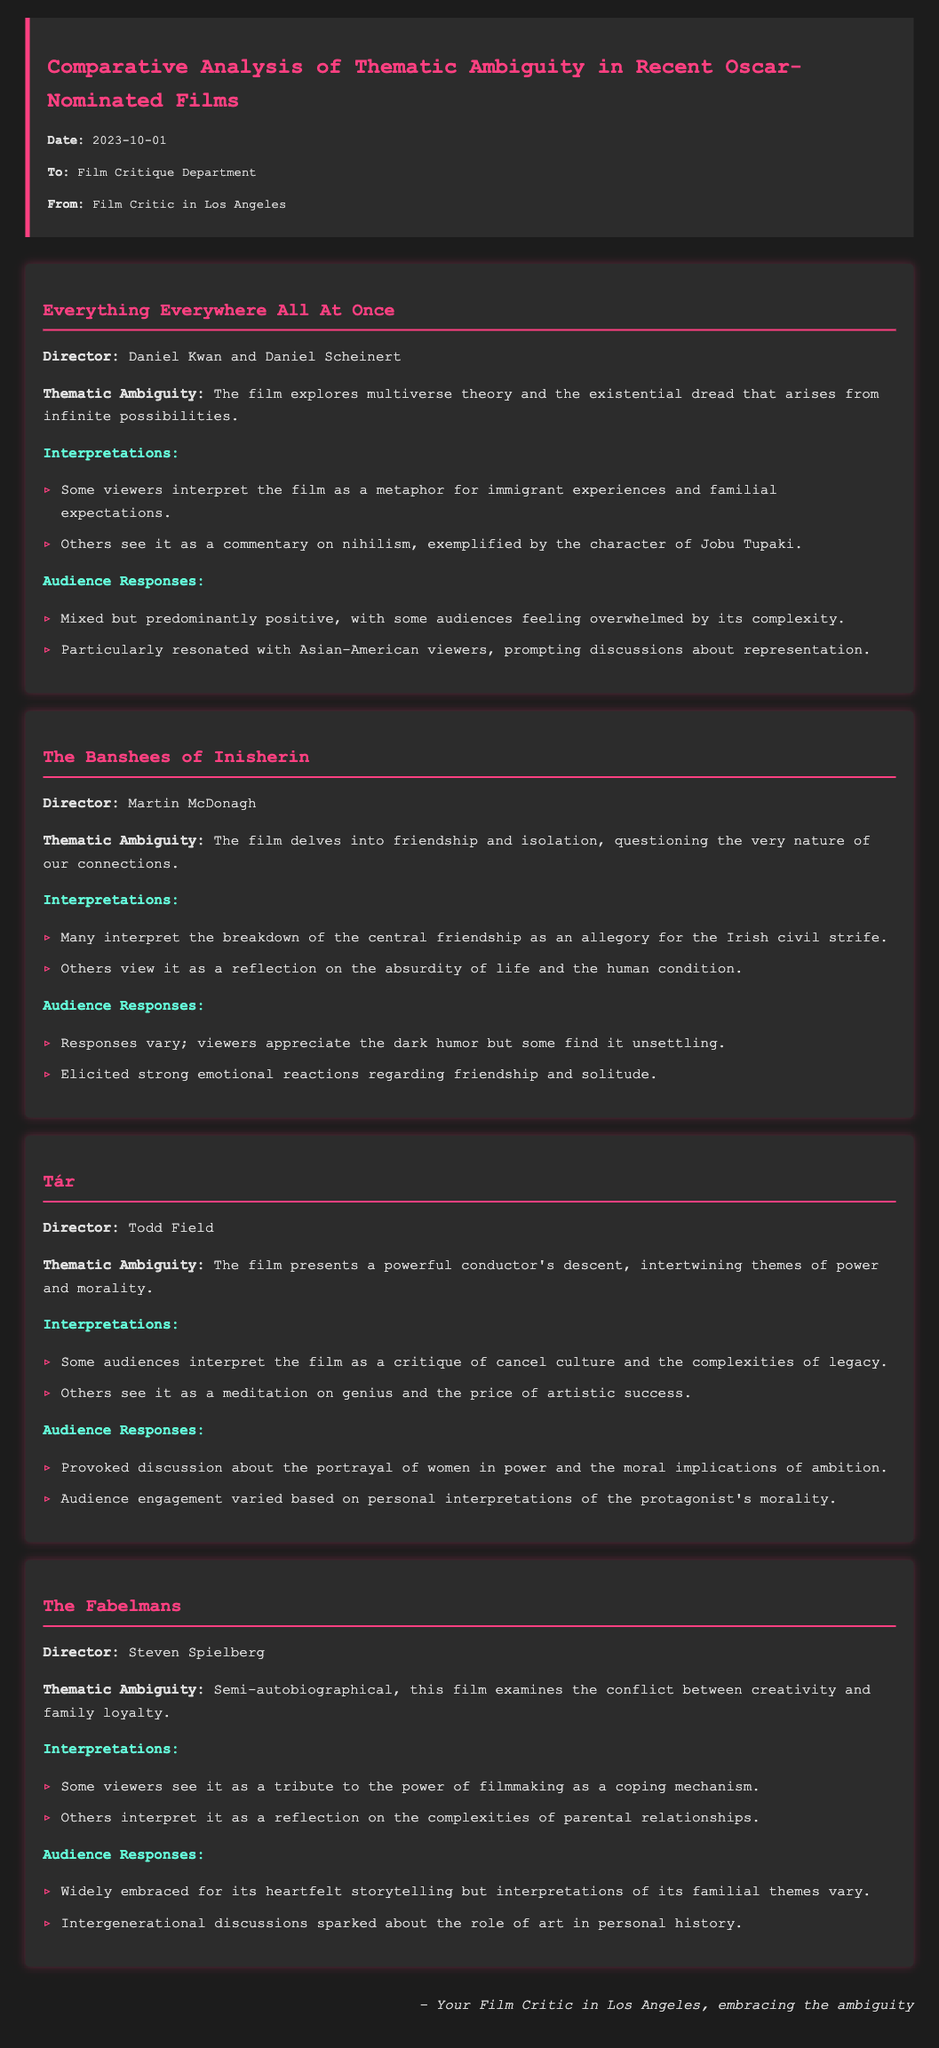What is the title of the memo? The title of the memo is indicated at the top of the document.
Answer: Comparative Analysis of Thematic Ambiguity in Recent Oscar-Nominated Films Who directed "Everything Everywhere All At Once"? The director's name is listed under the film section for "Everything Everywhere All At Once."
Answer: Daniel Kwan and Daniel Scheinert What theme is explored in "The Banshees of Inisherin"? The thematic ambiguity for "The Banshees of Inisherin" is provided in that specific section.
Answer: Friendship and isolation What type of responses did "Tár" provoke? The film section details the audience responses to "Tár."
Answer: Discussion about the portrayal of women in power Which film examines the conflict between creativity and family loyalty? The thematic ambiguity section for "The Fabelmans" mentions this specific conflict.
Answer: The Fabelmans How many themes are mentioned for "Tár"? The interpretations section lists multiple perspectives on themes for "Tár."
Answer: Two What emotional reactions were elicited by "The Banshees of Inisherin"? The audience responses section describes the emotional impact of the film.
Answer: Strong emotional reactions regarding friendship and solitude What date is on the memo? The date is clearly stated in the memo details at the top of the document.
Answer: 2023-10-01 What color is used for the title of the memo? The title's color is specified in the document formatting for the header.
Answer: Pink 